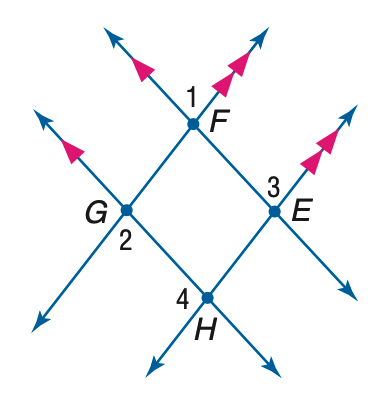Question: If m \angle 1 = 3 x + 40, m \angle 2 = 2(y - 10), and m \angle 3 = 2 x + 70, find x.
Choices:
A. 30
B. 40
C. 70
D. 75
Answer with the letter. Answer: A 